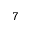Convert formula to latex. <formula><loc_0><loc_0><loc_500><loc_500>7</formula> 